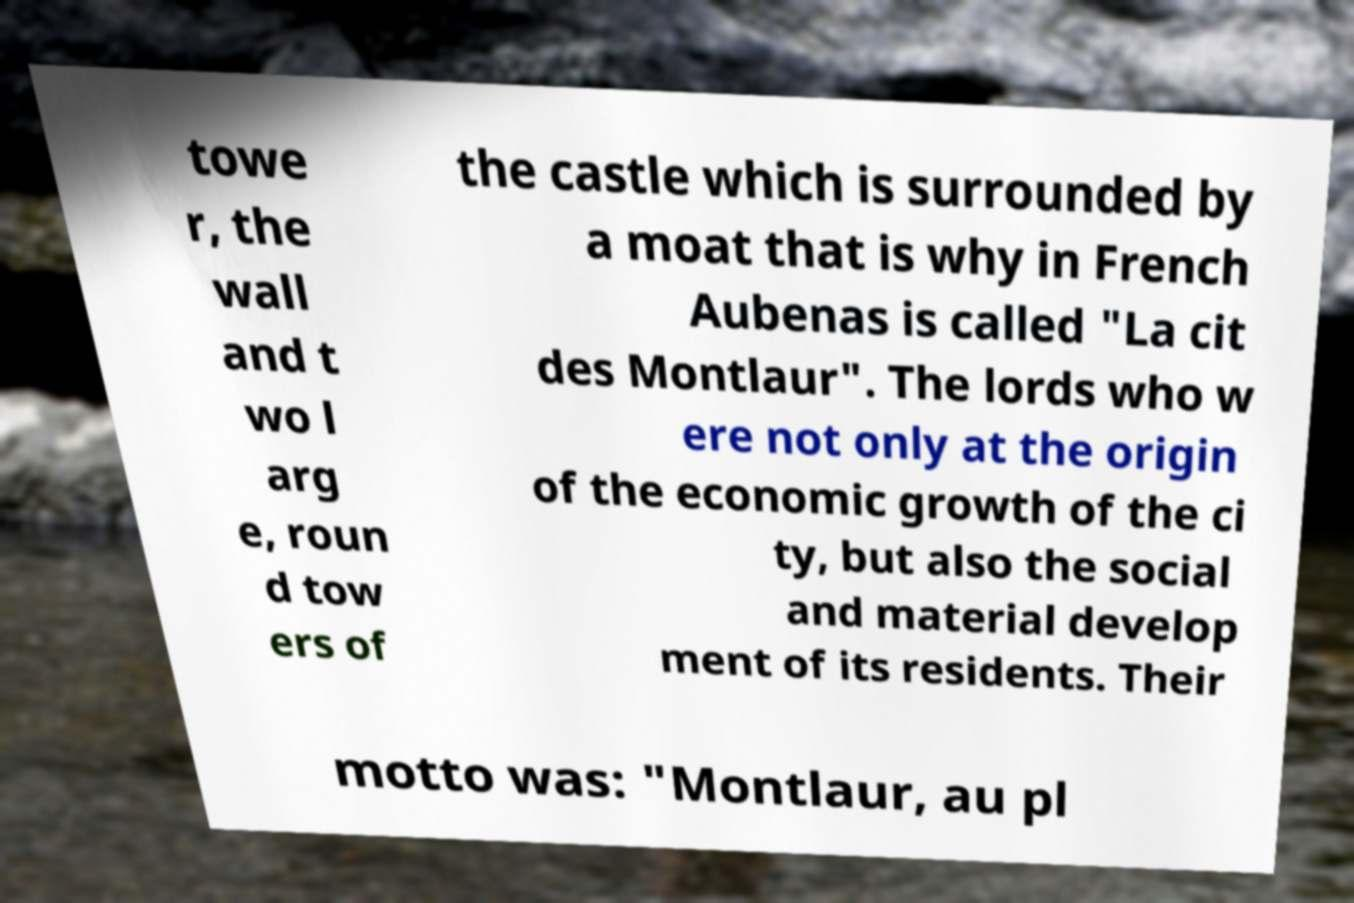There's text embedded in this image that I need extracted. Can you transcribe it verbatim? towe r, the wall and t wo l arg e, roun d tow ers of the castle which is surrounded by a moat that is why in French Aubenas is called "La cit des Montlaur". The lords who w ere not only at the origin of the economic growth of the ci ty, but also the social and material develop ment of its residents. Their motto was: "Montlaur, au pl 